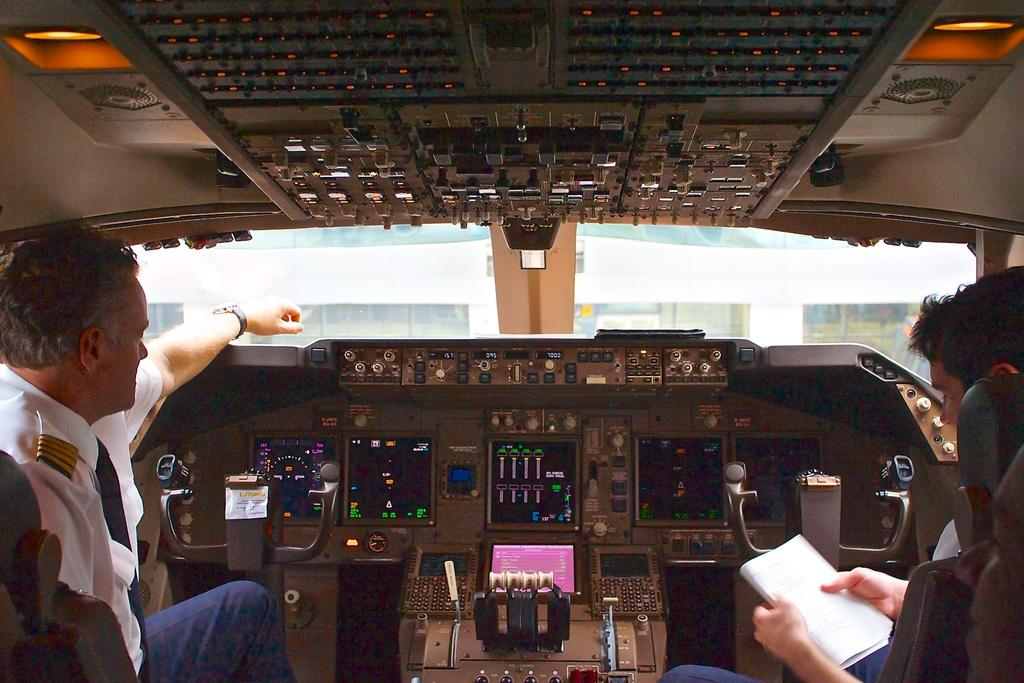How many people are in the image? There are two people in the image. What are the people doing in the image? The people are sitting on seats and holding books. What can be seen in the background of the image? There is a cockpit visible in the image. Can you see a flock of trees in the image? There is no mention of trees or a flock of trees in the image. The focus is on the two people and the cockpit. 